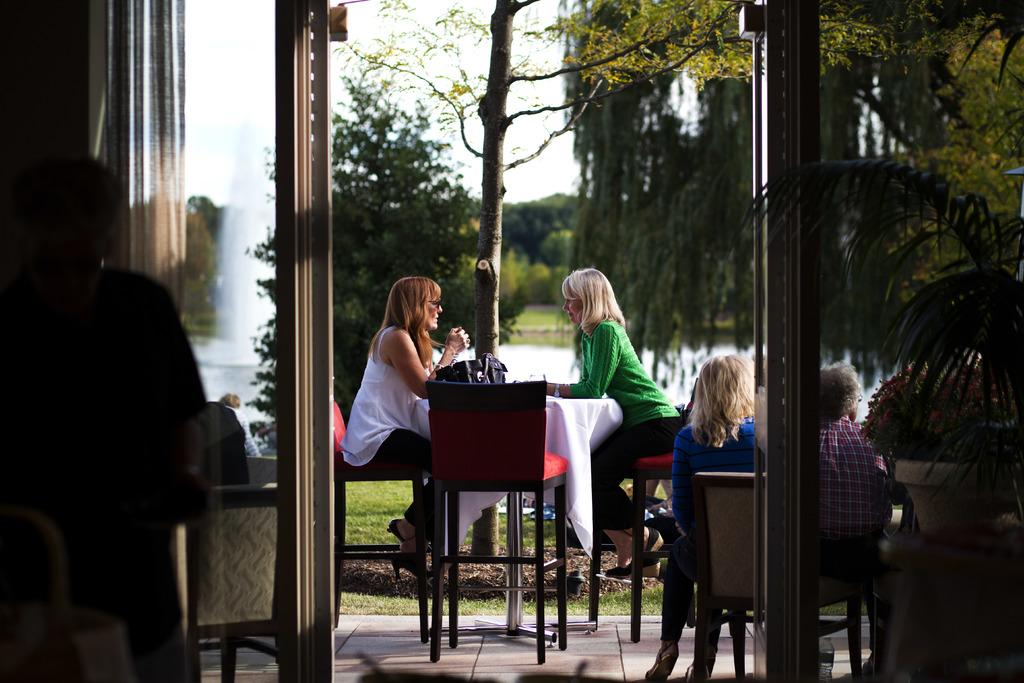What are the people in the image doing? The people in the image are sitting on chairs. What objects are present in the image that the people might be using? There are tables in the image that the people might be using. What additional item can be seen in the image? There is a bag in the image. What type of natural scenery is visible in the image? There are trees in the image. How does the bag provide support for the trees in the image? The bag does not provide support for the trees in the image; it is a separate item that is not connected to the trees. 